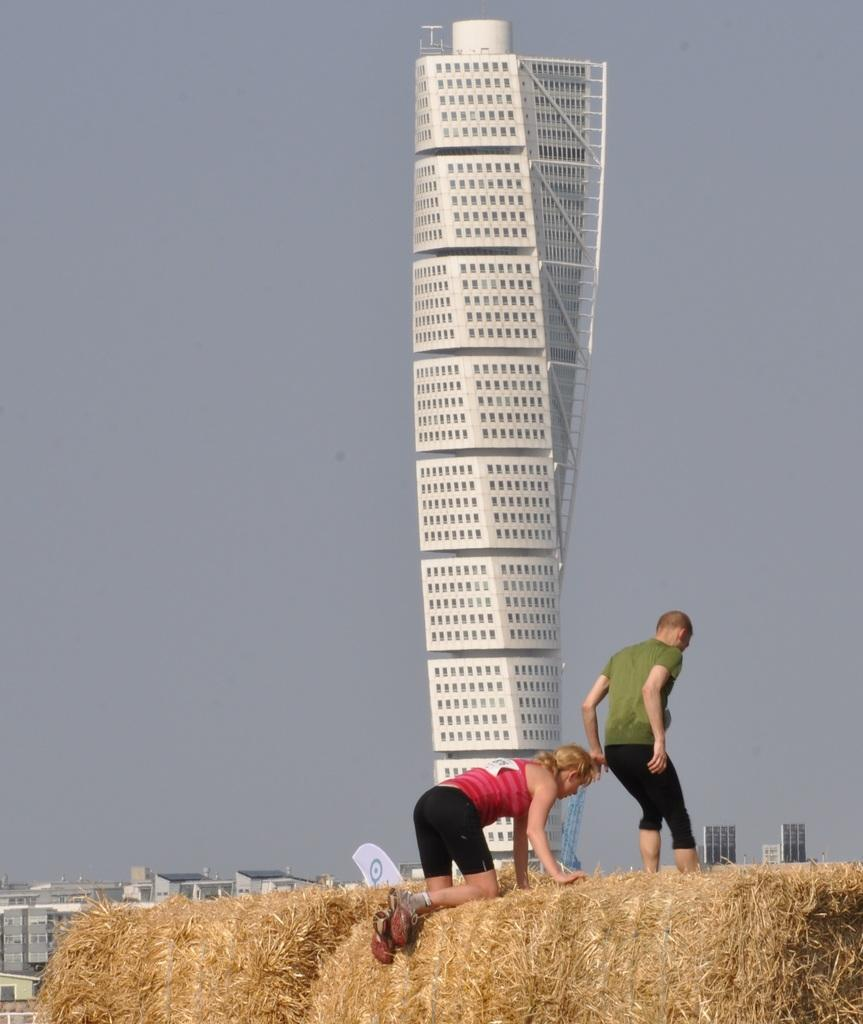How many people are in the foreground of the image? There are two persons in the foreground of the image. What is located in the foreground of the image besides the people? There is a grass load in the foreground of the image. What can be seen in the background of the image? There are buildings and a tower in the background of the image, as well as the sky. When was the image taken? The image was taken during the day. What type of argument can be seen taking place between the children in the image? There are no children present in the image, and therefore no argument can be observed. 